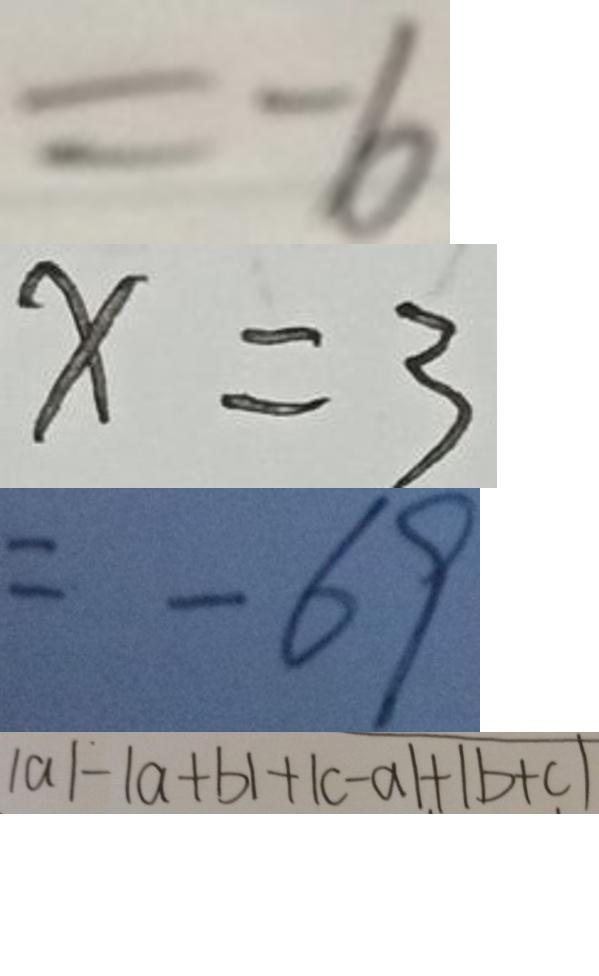<formula> <loc_0><loc_0><loc_500><loc_500>= - 6 
 x = 3 
 = - 6 9 
 \vert a \vert - \vert a + b \vert + \vert c - a \vert + \vert b + c \vert</formula> 